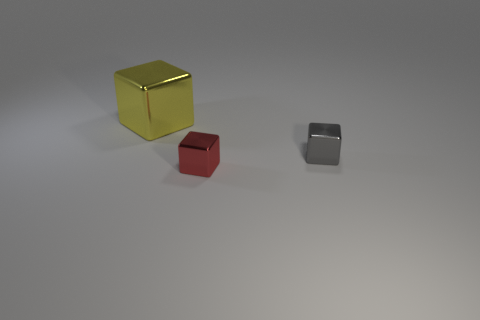What number of rubber things are tiny red blocks or large purple objects?
Keep it short and to the point. 0. Are there any shiny objects that are behind the cube that is on the right side of the tiny red shiny thing?
Provide a short and direct response. Yes. What number of things are either shiny things that are to the right of the red shiny object or cubes on the left side of the small gray thing?
Make the answer very short. 3. Is there any other thing that is the same color as the large metal block?
Offer a terse response. No. What is the color of the metallic block on the left side of the metallic block that is in front of the tiny cube behind the red thing?
Offer a terse response. Yellow. There is a thing that is in front of the metal block that is to the right of the tiny red metal thing; what is its size?
Give a very brief answer. Small. There is a gray thing; is its size the same as the object in front of the tiny gray object?
Provide a succinct answer. Yes. Is there a small cyan matte sphere?
Give a very brief answer. No. What is the material of the big yellow thing that is the same shape as the tiny red object?
Make the answer very short. Metal. How big is the shiny cube on the left side of the small metallic object that is in front of the small thing that is behind the red metallic cube?
Your response must be concise. Large. 